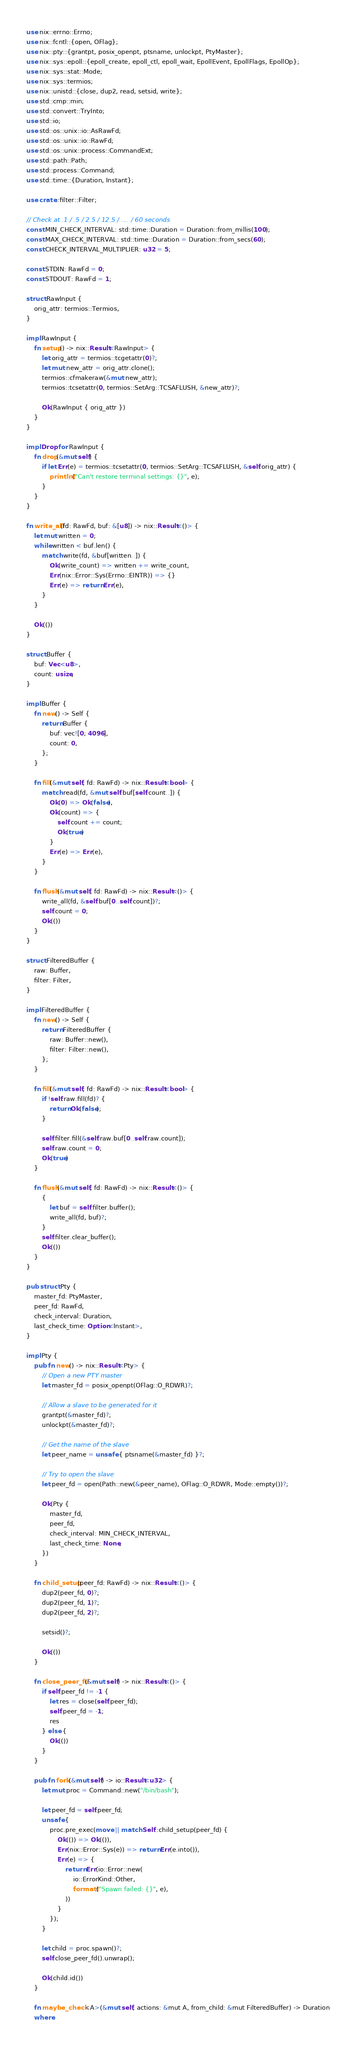Convert code to text. <code><loc_0><loc_0><loc_500><loc_500><_Rust_>use nix::errno::Errno;
use nix::fcntl::{open, OFlag};
use nix::pty::{grantpt, posix_openpt, ptsname, unlockpt, PtyMaster};
use nix::sys::epoll::{epoll_create, epoll_ctl, epoll_wait, EpollEvent, EpollFlags, EpollOp};
use nix::sys::stat::Mode;
use nix::sys::termios;
use nix::unistd::{close, dup2, read, setsid, write};
use std::cmp::min;
use std::convert::TryInto;
use std::io;
use std::os::unix::io::AsRawFd;
use std::os::unix::io::RawFd;
use std::os::unix::process::CommandExt;
use std::path::Path;
use std::process::Command;
use std::time::{Duration, Instant};

use crate::filter::Filter;

// Check at .1 / .5 / 2.5 / 12.5 / .... / 60 seconds
const MIN_CHECK_INTERVAL: std::time::Duration = Duration::from_millis(100);
const MAX_CHECK_INTERVAL: std::time::Duration = Duration::from_secs(60);
const CHECK_INTERVAL_MULTIPLIER: u32 = 5;

const STDIN: RawFd = 0;
const STDOUT: RawFd = 1;

struct RawInput {
    orig_attr: termios::Termios,
}

impl RawInput {
    fn setup() -> nix::Result<RawInput> {
        let orig_attr = termios::tcgetattr(0)?;
        let mut new_attr = orig_attr.clone();
        termios::cfmakeraw(&mut new_attr);
        termios::tcsetattr(0, termios::SetArg::TCSAFLUSH, &new_attr)?;

        Ok(RawInput { orig_attr })
    }
}

impl Drop for RawInput {
    fn drop(&mut self) {
        if let Err(e) = termios::tcsetattr(0, termios::SetArg::TCSAFLUSH, &self.orig_attr) {
            println!("Can't restore terminal settings: {}", e);
        }
    }
}

fn write_all(fd: RawFd, buf: &[u8]) -> nix::Result<()> {
    let mut written = 0;
    while written < buf.len() {
        match write(fd, &buf[written..]) {
            Ok(write_count) => written += write_count,
            Err(nix::Error::Sys(Errno::EINTR)) => {}
            Err(e) => return Err(e),
        }
    }

    Ok(())
}

struct Buffer {
    buf: Vec<u8>,
    count: usize,
}

impl Buffer {
    fn new() -> Self {
        return Buffer {
            buf: vec![0; 4096],
            count: 0,
        };
    }

    fn fill(&mut self, fd: RawFd) -> nix::Result<bool> {
        match read(fd, &mut self.buf[self.count..]) {
            Ok(0) => Ok(false),
            Ok(count) => {
                self.count += count;
                Ok(true)
            }
            Err(e) => Err(e),
        }
    }

    fn flush(&mut self, fd: RawFd) -> nix::Result<()> {
        write_all(fd, &self.buf[0..self.count])?;
        self.count = 0;
        Ok(())
    }
}

struct FilteredBuffer {
    raw: Buffer,
    filter: Filter,
}

impl FilteredBuffer {
    fn new() -> Self {
        return FilteredBuffer {
            raw: Buffer::new(),
            filter: Filter::new(),
        };
    }

    fn fill(&mut self, fd: RawFd) -> nix::Result<bool> {
        if !self.raw.fill(fd)? {
            return Ok(false);
        }

        self.filter.fill(&self.raw.buf[0..self.raw.count]);
        self.raw.count = 0;
        Ok(true)
    }

    fn flush(&mut self, fd: RawFd) -> nix::Result<()> {
        {
            let buf = self.filter.buffer();
            write_all(fd, buf)?;
        }
        self.filter.clear_buffer();
        Ok(())
    }
}

pub struct Pty {
    master_fd: PtyMaster,
    peer_fd: RawFd,
    check_interval: Duration,
    last_check_time: Option<Instant>,
}

impl Pty {
    pub fn new() -> nix::Result<Pty> {
        // Open a new PTY master
        let master_fd = posix_openpt(OFlag::O_RDWR)?;

        // Allow a slave to be generated for it
        grantpt(&master_fd)?;
        unlockpt(&master_fd)?;

        // Get the name of the slave
        let peer_name = unsafe { ptsname(&master_fd) }?;

        // Try to open the slave
        let peer_fd = open(Path::new(&peer_name), OFlag::O_RDWR, Mode::empty())?;

        Ok(Pty {
            master_fd,
            peer_fd,
            check_interval: MIN_CHECK_INTERVAL,
            last_check_time: None,
        })
    }

    fn child_setup(peer_fd: RawFd) -> nix::Result<()> {
        dup2(peer_fd, 0)?;
        dup2(peer_fd, 1)?;
        dup2(peer_fd, 2)?;

        setsid()?;

        Ok(())
    }

    fn close_peer_fd(&mut self) -> nix::Result<()> {
        if self.peer_fd != -1 {
            let res = close(self.peer_fd);
            self.peer_fd = -1;
            res
        } else {
            Ok(())
        }
    }

    pub fn fork(&mut self) -> io::Result<u32> {
        let mut proc = Command::new("/bin/bash");

        let peer_fd = self.peer_fd;
        unsafe {
            proc.pre_exec(move || match Self::child_setup(peer_fd) {
                Ok(()) => Ok(()),
                Err(nix::Error::Sys(e)) => return Err(e.into()),
                Err(e) => {
                    return Err(io::Error::new(
                        io::ErrorKind::Other,
                        format!("Spawn failed: {}", e),
                    ))
                }
            });
        }

        let child = proc.spawn()?;
        self.close_peer_fd().unwrap();

        Ok(child.id())
    }

    fn maybe_check<A>(&mut self, actions: &mut A, from_child: &mut FilteredBuffer) -> Duration
    where</code> 